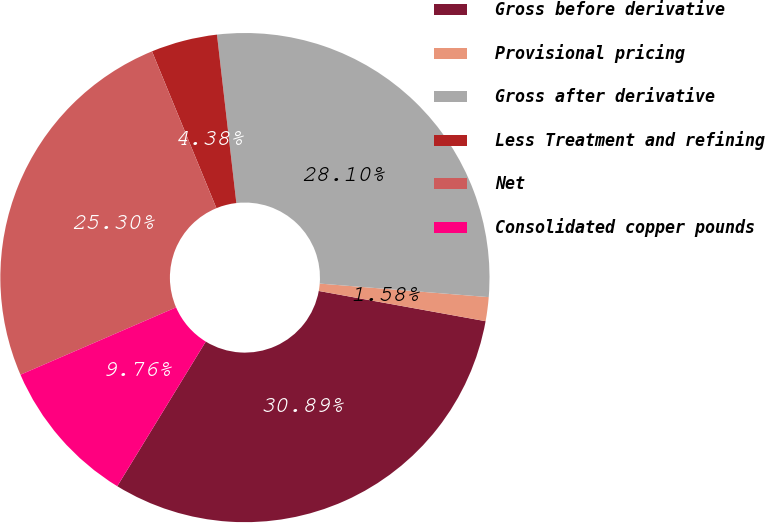Convert chart. <chart><loc_0><loc_0><loc_500><loc_500><pie_chart><fcel>Gross before derivative<fcel>Provisional pricing<fcel>Gross after derivative<fcel>Less Treatment and refining<fcel>Net<fcel>Consolidated copper pounds<nl><fcel>30.89%<fcel>1.58%<fcel>28.1%<fcel>4.38%<fcel>25.3%<fcel>9.76%<nl></chart> 